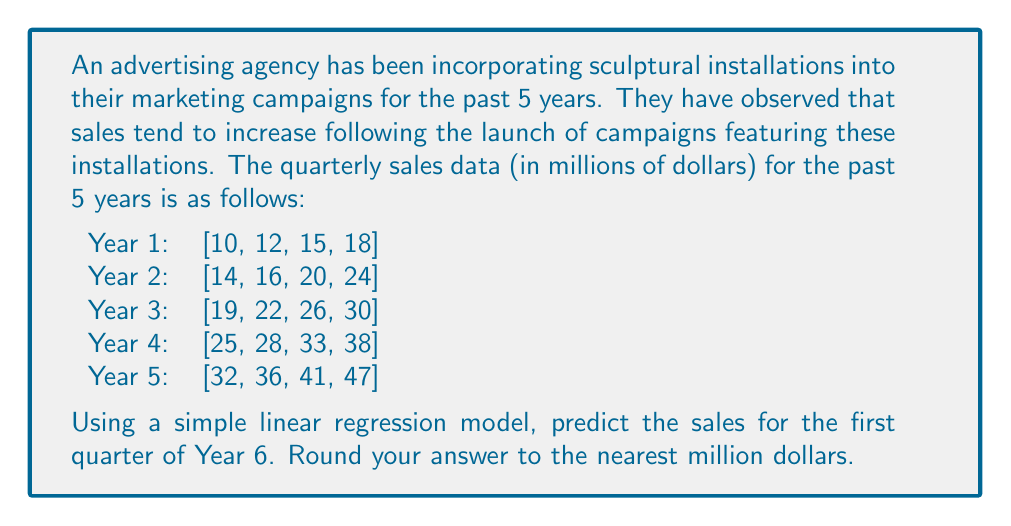Can you solve this math problem? To predict future sales using a simple linear regression model, we'll follow these steps:

1) First, we need to arrange our data into x (time periods) and y (sales) coordinates:

   x: [1, 2, 3, 4, 5, 6, 7, 8, 9, 10, 11, 12, 13, 14, 15, 16, 17, 18, 19, 20]
   y: [10, 12, 15, 18, 14, 16, 20, 24, 19, 22, 26, 30, 25, 28, 33, 38, 32, 36, 41, 47]

2) The linear regression equation is:

   $$y = mx + b$$

   where m is the slope and b is the y-intercept.

3) To find m and b, we use these formulas:

   $$m = \frac{n\sum xy - \sum x \sum y}{n\sum x^2 - (\sum x)^2}$$

   $$b = \frac{\sum y - m\sum x}{n}$$

   where n is the number of data points.

4) Calculate the required sums:

   $n = 20$
   $\sum x = 210$
   $\sum y = 506$
   $\sum xy = 6,391$
   $\sum x^2 = 2,870$

5) Plug these into the formulas:

   $$m = \frac{20(6,391) - 210(506)}{20(2,870) - 210^2} = 1.8547$$

   $$b = \frac{506 - 1.8547(210)}{20} = 6.6257$$

6) Our regression equation is thus:

   $$y = 1.8547x + 6.6257$$

7) To predict the sales for the first quarter of Year 6, we need to use x = 21:

   $$y = 1.8547(21) + 6.6257 = 45.5744$$

8) Rounding to the nearest million:

   $$y ≈ 46$$
Answer: $46 million 